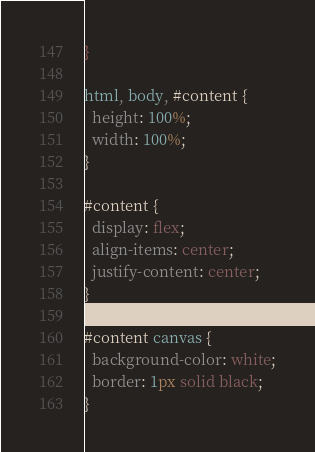<code> <loc_0><loc_0><loc_500><loc_500><_CSS_>}

html, body, #content {
  height: 100%;
  width: 100%;
}

#content {
  display: flex;
  align-items: center;
  justify-content: center;
}

#content canvas {
  background-color: white;
  border: 1px solid black;
}
</code> 